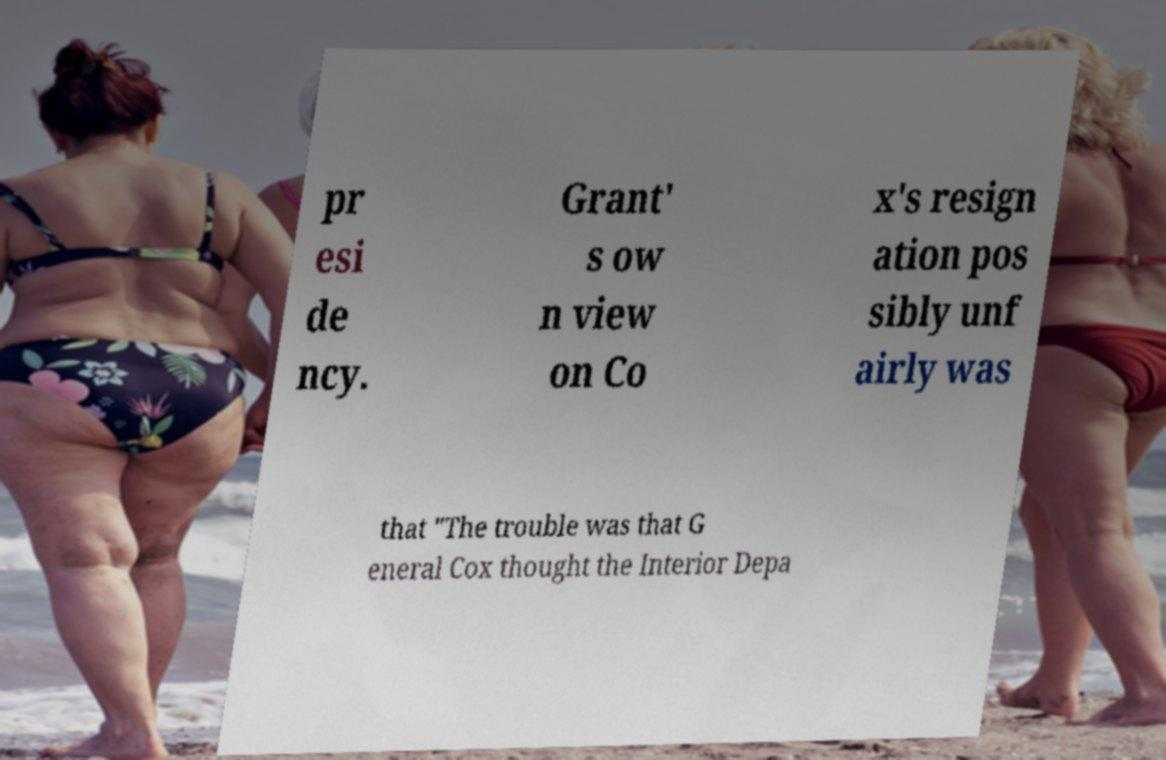What messages or text are displayed in this image? I need them in a readable, typed format. pr esi de ncy. Grant' s ow n view on Co x's resign ation pos sibly unf airly was that "The trouble was that G eneral Cox thought the Interior Depa 